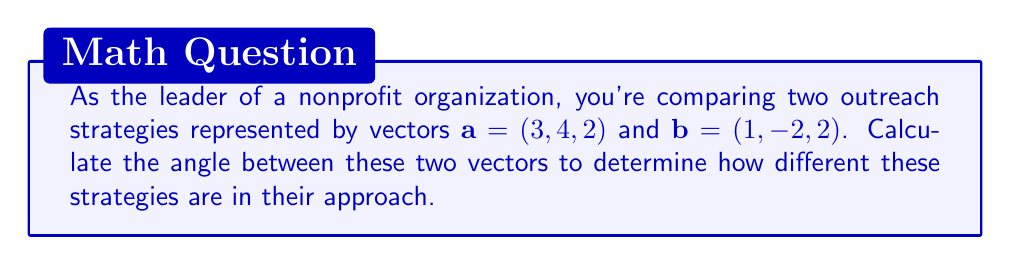Teach me how to tackle this problem. To find the angle between two vectors, we can use the dot product formula:

$$\cos \theta = \frac{\mathbf{a} \cdot \mathbf{b}}{|\mathbf{a}||\mathbf{b}|}$$

Where $\mathbf{a} \cdot \mathbf{b}$ is the dot product of the vectors, and $|\mathbf{a}|$ and $|\mathbf{b}|$ are the magnitudes of vectors $\mathbf{a}$ and $\mathbf{b}$ respectively.

Step 1: Calculate the dot product $\mathbf{a} \cdot \mathbf{b}$
$$\mathbf{a} \cdot \mathbf{b} = (3)(1) + (4)(-2) + (2)(2) = 3 - 8 + 4 = -1$$

Step 2: Calculate the magnitudes of $\mathbf{a}$ and $\mathbf{b}$
$$|\mathbf{a}| = \sqrt{3^2 + 4^2 + 2^2} = \sqrt{9 + 16 + 4} = \sqrt{29}$$
$$|\mathbf{b}| = \sqrt{1^2 + (-2)^2 + 2^2} = \sqrt{1 + 4 + 4} = 3$$

Step 3: Substitute into the formula
$$\cos \theta = \frac{-1}{(\sqrt{29})(3)}$$

Step 4: Solve for $\theta$
$$\theta = \arccos\left(\frac{-1}{(\sqrt{29})(3)}\right)$$

Step 5: Calculate the final answer (in radians)
$$\theta \approx 1.76 \text{ radians}$$

Step 6: Convert to degrees
$$\theta \approx 1.76 \times \frac{180}{\pi} \approx 100.9°$$
Answer: The angle between the two vectors is approximately 100.9°. 